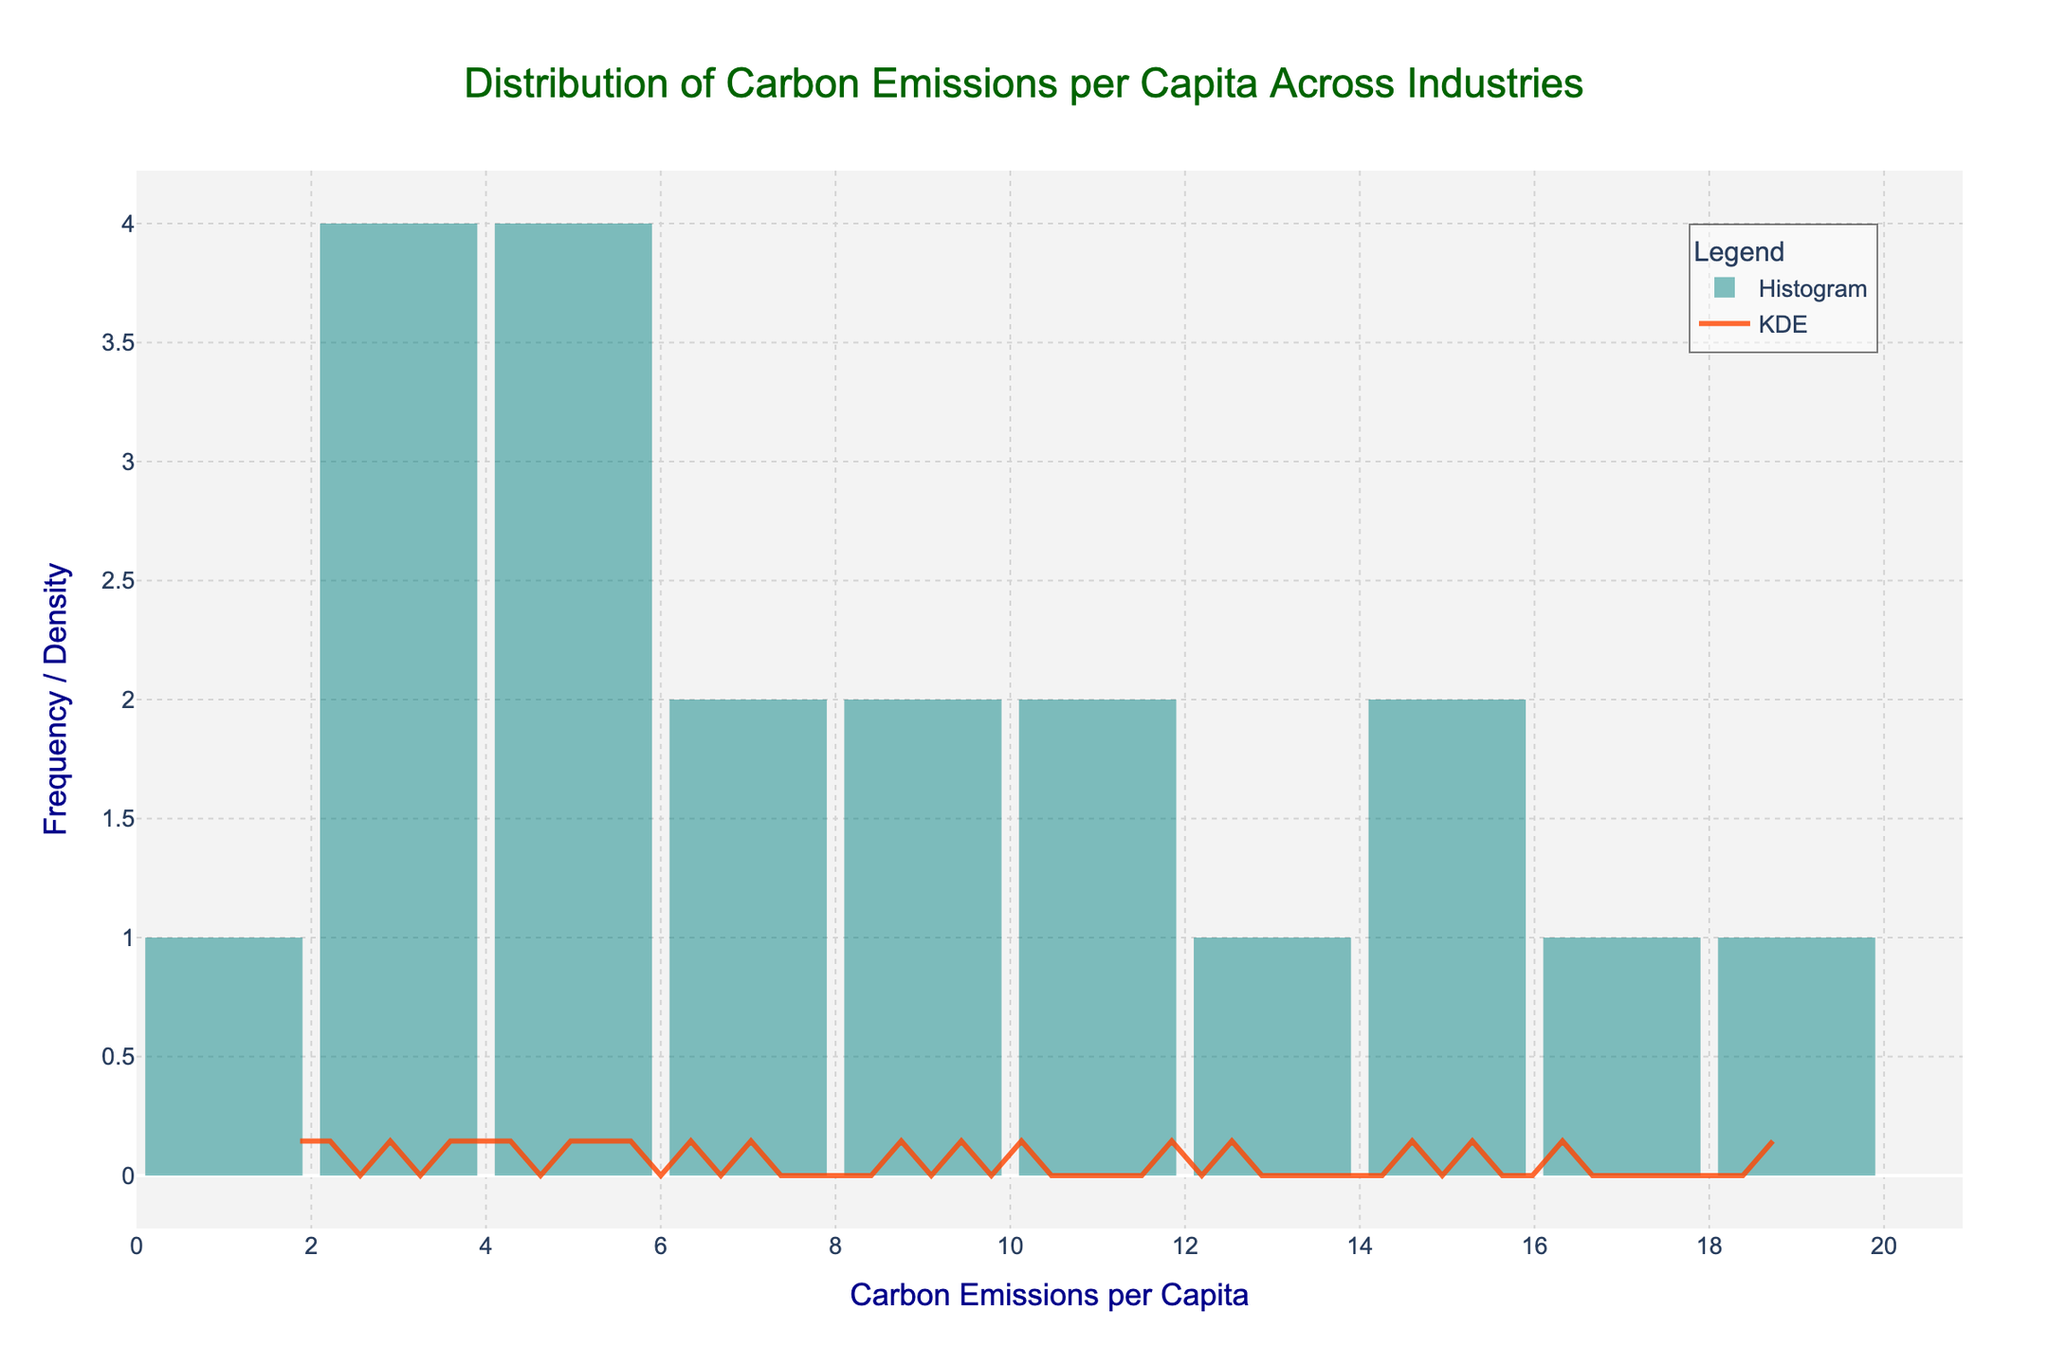What is the range of carbon emissions per capita in the figure? The x-axis indicates carbon emissions per capita, ranging from 0 to a bit over 20 (the highest bin being around 20).
Answer: 0 to approximately 20 Which industry has the highest carbon emissions per capita? By referring to the x-axis and overlaying the histogram data with industry names from the background, we see that the Oil and Gas Extraction industry has the highest emission value around 18.9.
Answer: Oil and Gas Extraction How is the distribution of carbon emissions per capita visually represented in the figure? The distribution is shown through both a histogram for frequency and a KDE curve for density. The histogram shows the frequency in different bins, and the KDE curve smoothens this to show a continuous density estimate.
Answer: Histogram and KDE curve At what carbon emission per capita value does the KDE curve peak? The KDE (density estimate) curve peaks at around 5, where the density of carbon emissions per capita is highest.
Answer: Around 5 What is the median of the carbon emissions per capita? To find the median, visually locate the middle value of the sorted data points. Given the KDE peak and distribution, the median appears to be between 6 and 7.
Answer: Around 6 to 7 Compare and contrast the emissions of the Mining industry and the Construction industry. Referring to the histogram bins: Mining has a higher carbon emission (about 12.7) compared to Construction (about 7.1).
Answer: Mining > Construction How many industries have carbon emissions per capita higher than 10? Count the histogram bins for values exceeding 10: Mining, Oil and Gas Extraction, Chemical Manufacturing, Steel Production, Energy Generation, and Cement Production total 6 industries.
Answer: 6 Describe the color coding used in the histogram and KDE curve. The histogram bars are colored in teal blue for frequency distribution, while the KDE curve is represented by a bright orange line.
Answer: Teal blue and orange What can be inferred about the skewness of the carbon emissions distribution? The KDE curve and histogram show a right-skewed distribution where the majority of industries are on the lower side, and a few have very high emissions.
Answer: Right-skewed Identify the industry with the lowest carbon emissions per capita. From the histogram and data points, the Information Technology (IT) industry has the lowest emissions at around 1.7.
Answer: Information Technology 